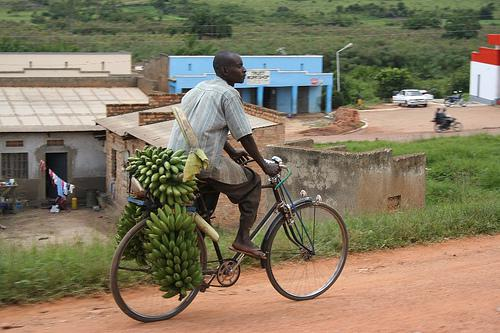Question: what is the man riding?
Choices:
A. Bicycle.
B. Motorcycle.
C. Segway.
D. Scooter.
Answer with the letter. Answer: A Question: how many cars are in the photo?
Choices:
A. 2.
B. 3.
C. 4.
D. 1.
Answer with the letter. Answer: D Question: what color pants is the man wearing?
Choices:
A. Brown.
B. Green.
C. Blue.
D. Red.
Answer with the letter. Answer: A Question: what kind of road is it?
Choices:
A. Dirt.
B. Gravel.
C. Trunk.
D. Ice.
Answer with the letter. Answer: A Question: what side of the photo is the man facing?
Choices:
A. Left.
B. North.
C. South.
D. Right.
Answer with the letter. Answer: D Question: what color are the bananas?
Choices:
A. Green.
B. Yellow.
C. Black.
D. Gold.
Answer with the letter. Answer: A Question: where was the photo taken?
Choices:
A. City street.
B. On the sidewalk.
C. Dirt road.
D. In a grassy field.
Answer with the letter. Answer: C 